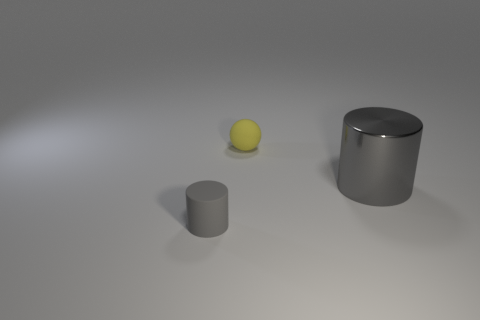There is a object that is in front of the large gray metal thing on the right side of the gray cylinder that is in front of the shiny object; what is its color?
Your answer should be compact. Gray. What number of other objects are the same shape as the yellow rubber object?
Provide a succinct answer. 0. Are there any big gray objects on the left side of the cylinder that is to the right of the small gray object?
Your response must be concise. No. How many matte objects are either large things or small cylinders?
Offer a very short reply. 1. There is a object that is both behind the tiny gray rubber object and in front of the matte sphere; what material is it?
Offer a very short reply. Metal. There is a gray cylinder on the right side of the small object behind the tiny gray matte cylinder; is there a large gray shiny cylinder on the right side of it?
Give a very brief answer. No. Is there any other thing that has the same material as the small gray cylinder?
Keep it short and to the point. Yes. What is the shape of the tiny gray object that is made of the same material as the tiny yellow object?
Your answer should be compact. Cylinder. Is the number of tiny yellow things that are right of the large gray metallic object less than the number of matte objects that are behind the small gray rubber cylinder?
Keep it short and to the point. Yes. How many large things are either metal cylinders or gray rubber cylinders?
Provide a short and direct response. 1. 